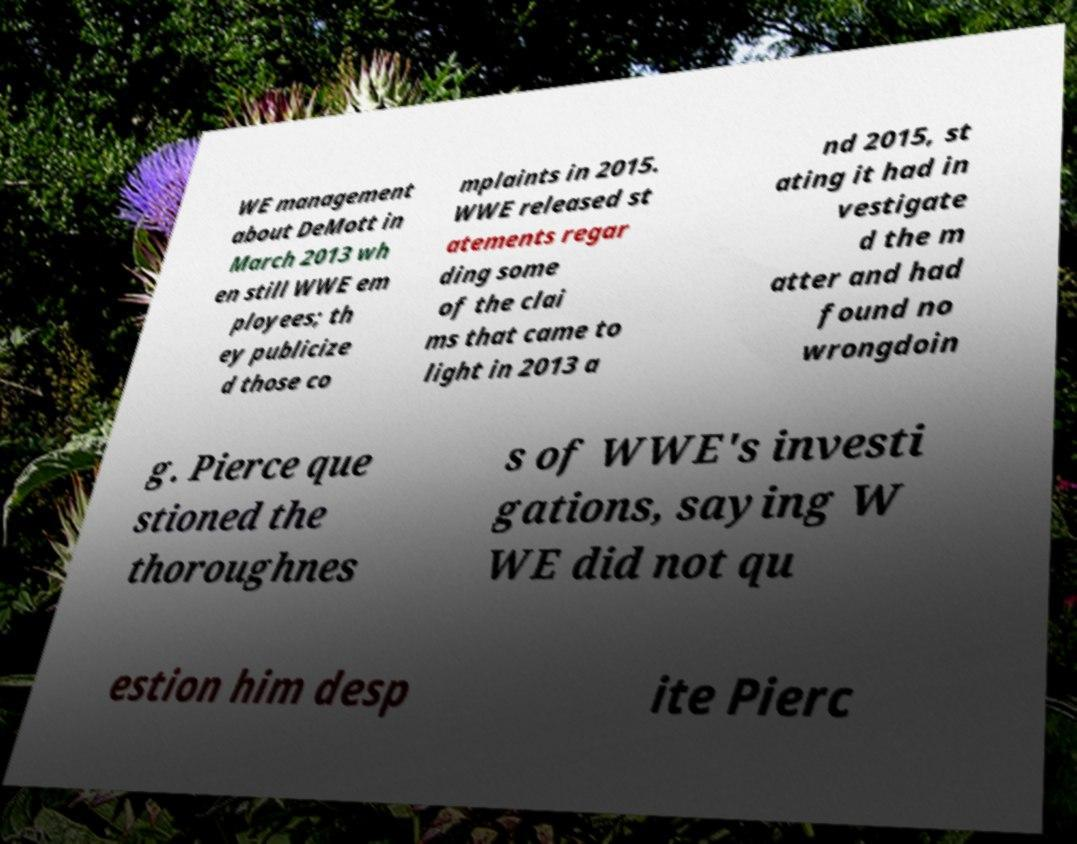Could you extract and type out the text from this image? WE management about DeMott in March 2013 wh en still WWE em ployees; th ey publicize d those co mplaints in 2015. WWE released st atements regar ding some of the clai ms that came to light in 2013 a nd 2015, st ating it had in vestigate d the m atter and had found no wrongdoin g. Pierce que stioned the thoroughnes s of WWE's investi gations, saying W WE did not qu estion him desp ite Pierc 